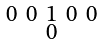Convert formula to latex. <formula><loc_0><loc_0><loc_500><loc_500>\begin{smallmatrix} 0 & 0 & 1 & 0 & 0 \\ & & 0 & & \end{smallmatrix}</formula> 